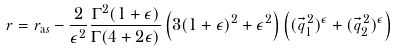<formula> <loc_0><loc_0><loc_500><loc_500>r = r _ { \mathrm a s } - \frac { 2 } { \epsilon ^ { 2 } } \frac { \Gamma ^ { 2 } ( 1 + \epsilon ) } { \Gamma ( 4 + 2 \epsilon ) } \left ( 3 ( 1 + \epsilon ) ^ { 2 } + \epsilon ^ { 2 } \right ) \left ( ( \vec { q } _ { 1 } ^ { \, 2 } ) ^ { \epsilon } + ( \vec { q } _ { 2 } ^ { \, 2 } ) ^ { \epsilon } \right )</formula> 